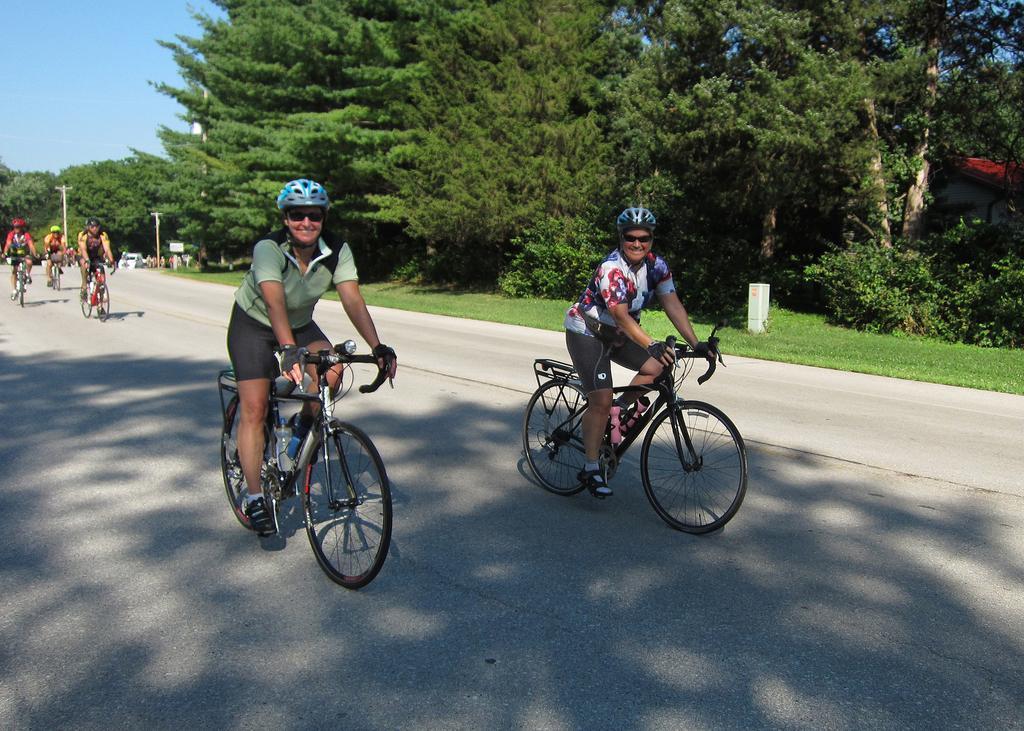Please provide a concise description of this image. In this image in front people are cycling on the road. On the right side of the image there is grass on the surface. In the background there are trees and sky. 